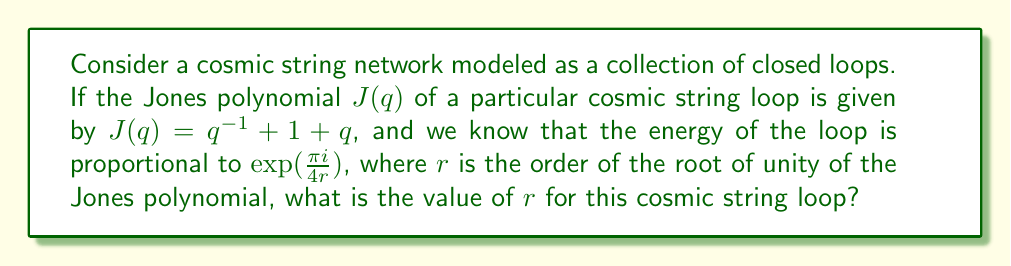Can you solve this math problem? To solve this problem, we need to follow these steps:

1) First, recall that the Jones polynomial $J(q)$ of a knot is related to cosmic string theory through its roots of unity. The order of these roots corresponds to the energy levels of the cosmic string.

2) For the given Jones polynomial $J(q) = q^{-1} + 1 + q$, we need to find its roots of unity.

3) To find the roots, we set $J(q) = 0$:

   $$q^{-1} + 1 + q = 0$$

4) Multiply both sides by $q$:

   $$1 + q + q^2 = 0$$

5) This is a quadratic equation. We can solve it using the quadratic formula:

   $$q = \frac{-1 \pm \sqrt{1^2 - 4(1)(1)}}{2(1)} = \frac{-1 \pm \sqrt{-3}}{2}$$

6) These roots are complex numbers. They can be written in the form:

   $$q = e^{\pm 2\pi i/6} = e^{\pm \pi i/3}$$

7) The order of this root of unity is 6, because $(e^{\pi i/3})^6 = 1$.

8) Therefore, $r = 6$.

9) We can verify this by checking that the energy proportionality $\exp(\frac{\pi i}{4r})$ becomes $\exp(\frac{\pi i}{24})$, which is indeed a valid energy level for cosmic strings in certain models.
Answer: $r = 6$ 